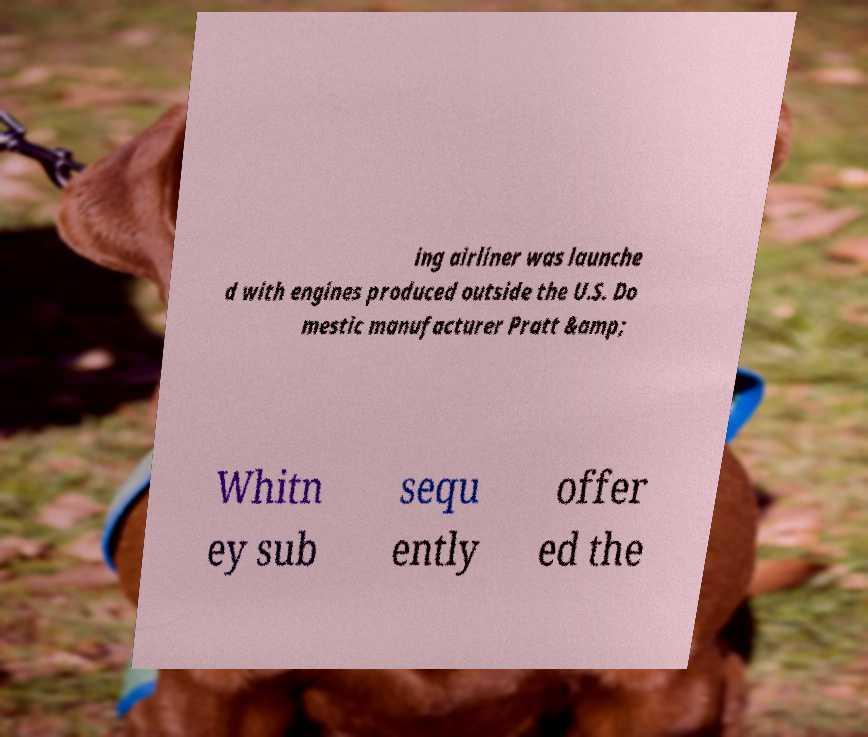Can you accurately transcribe the text from the provided image for me? ing airliner was launche d with engines produced outside the U.S. Do mestic manufacturer Pratt &amp; Whitn ey sub sequ ently offer ed the 